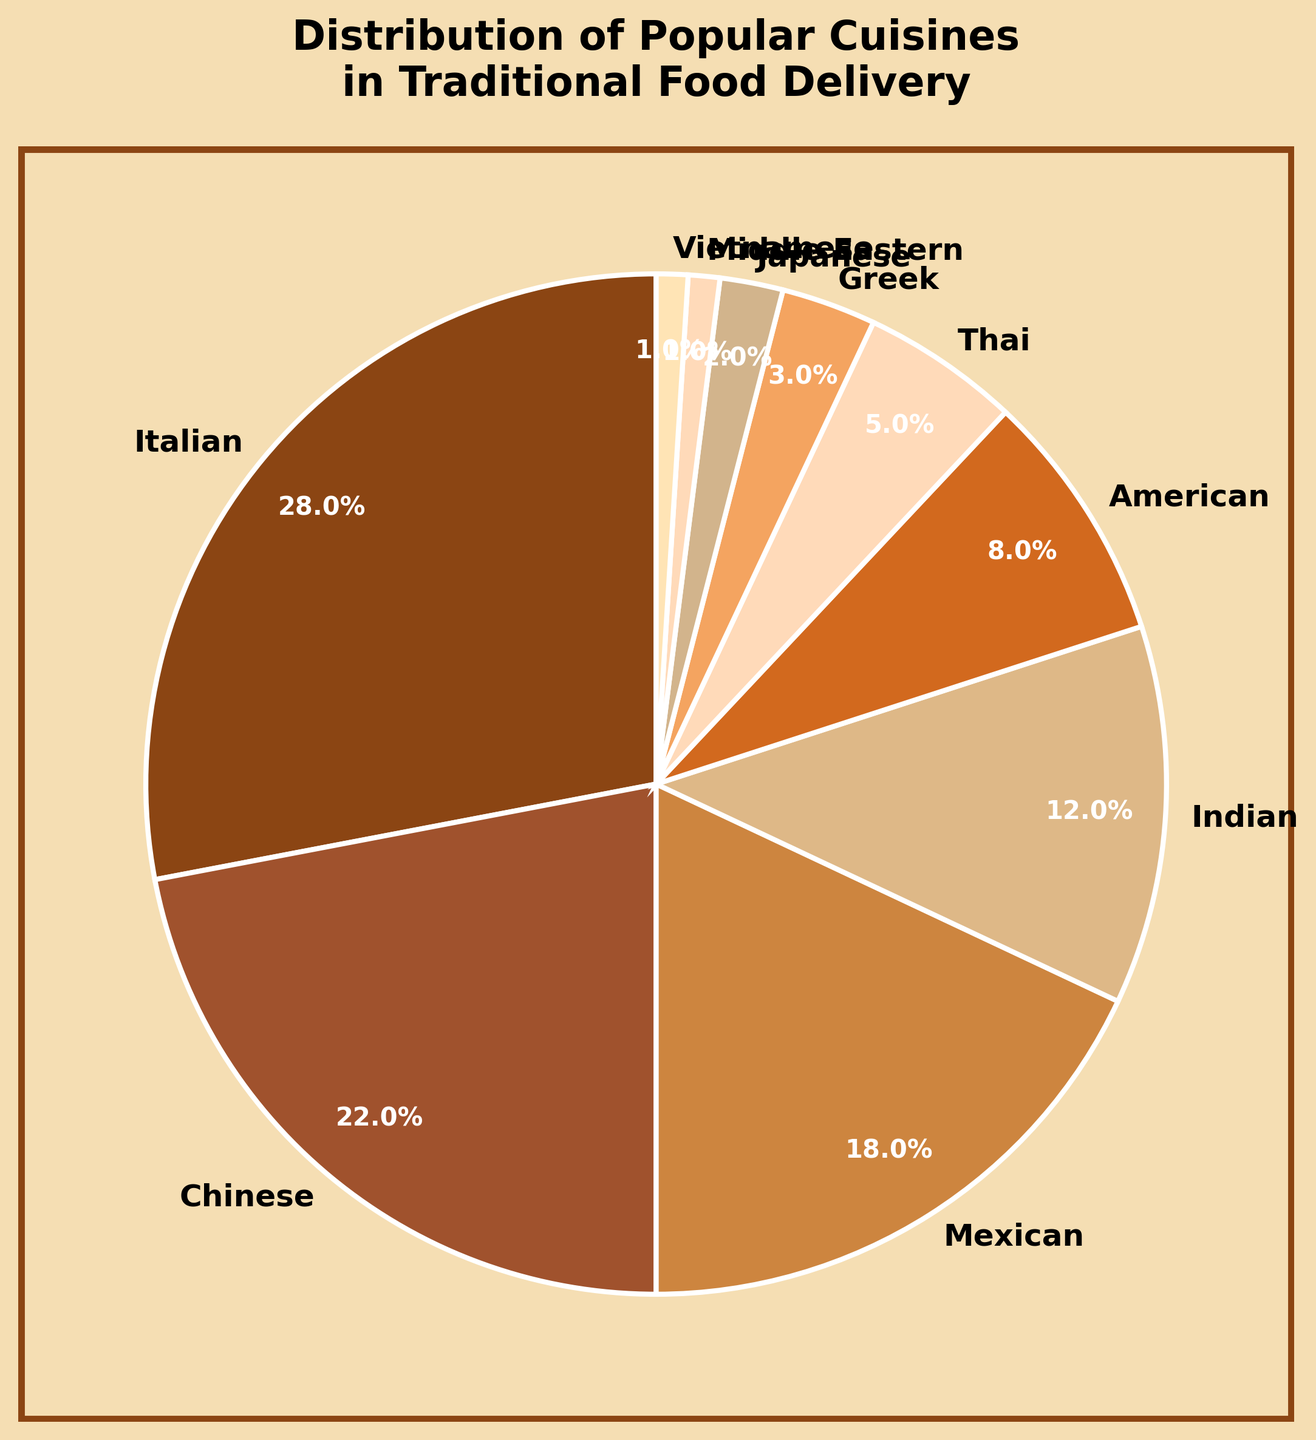What's the most popular cuisine in the traditional food delivery service? First, identify the cuisine with the highest percentage shown in the pie chart. The largest wedge represents Italian cuisine with 28%.
Answer: Italian Which cuisine is more popular, Indian or American? Compare the percentages for Indian (12%) and American (8%) cuisines. Since 12% is greater than 8%, Indian is more popular.
Answer: Indian What is the combined percentage of Mexican and Chinese cuisines? Add the percentages of Mexican (18%) and Chinese (22%) cuisines. 18 + 22 = 40.
Answer: 40% Is Thai cuisine more or less popular than Greek cuisine? Compare the percentages for Thai (5%) and Greek (3%) cuisines. Since 5% is greater than 3%, Thai cuisine is more popular.
Answer: More What’s the percentage difference between the most popular and the least popular cuisine? The most popular (Italian) has 28%, and the least popular (Middle Eastern and Vietnamese) each has 1%. Subtract the least from the most: 28 - 1 = 27.
Answer: 27% What cuisines make up more than half of the total orders combined? Calculate if the combination of the top cuisines exceeds 50%. Italian (28%) + Chinese (22%) = 50%, so adding any more cuisine will exceed 50%. Italian and Chinese together make up more than half.
Answer: Italian and Chinese Between Japanese and Middle Eastern cuisines, which one has a smaller share, and by how much? Compare the percentages: Japanese (2%) and Middle Eastern (1%). The difference is 1%.
Answer: Middle Eastern, by 1% What proportion of the chart represents Asian cuisines (Chinese, Indian, Thai, Japanese, and Vietnamese combined)? Sum their percentages: Chinese (22%) + Indian (12%) + Thai (5%) + Japanese (2%) + Vietnamese (1%) = 42%.
Answer: 42% Is the color representing American cuisine darker or lighter than the color for Mexican cuisine? Visually compare the colors of American (a lighter brown hue) and Mexican (a medium brown hue) cuisines. The American wedge is lighter.
Answer: Lighter 